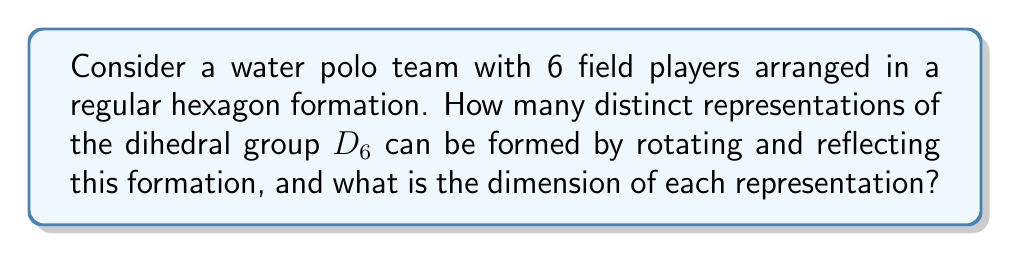What is the answer to this math problem? Let's approach this step-by-step:

1) The dihedral group $D_6$ has 12 elements: 6 rotations and 6 reflections.

2) To find the representations, we need to consider how these elements act on the hexagon formation:

   a) The trivial representation: This is always present and has dimension 1.
   
   b) The sign representation: This assigns +1 to rotations and -1 to reflections, also of dimension 1.
   
   c) The standard 2-dimensional representation: This comes from the natural action of $D_6$ on the plane. It's irreducible and of dimension 2.

3) To find additional representations, we need to consider how $D_6$ acts on the vertices of the hexagon:

   d) Let $\omega = e^{2\pi i/6}$. We can define two more 1-dimensional representations:
      $\chi_1(r) = \omega$, $\chi_1(s) = 1$
      $\chi_2(r) = \omega^2$, $\chi_2(s) = 1$
      Where $r$ is a rotation by $\pi/3$ and $s$ is a reflection.

   e) Finally, there's one more 2-dimensional irreducible representation, which can be constructed using the character table of $D_6$.

4) In total, we have:
   - 4 representations of dimension 1
   - 2 representations of dimension 2

5) The sum of the squares of these dimensions should equal the order of the group:
   $4(1^2) + 2(2^2) = 4 + 8 = 12$, which confirms our count.

Therefore, there are 6 distinct irreducible representations of $D_6$ in this context.
Answer: 6 representations: 4 of dimension 1, 2 of dimension 2 